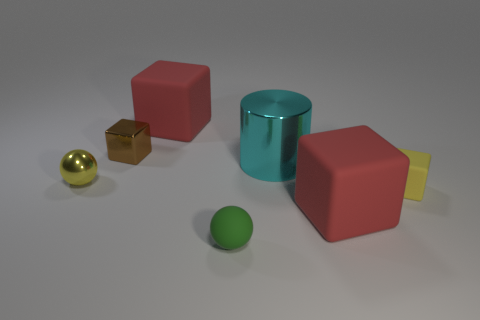Does the small rubber object that is on the right side of the metal cylinder have the same color as the large rubber object that is in front of the yellow metallic sphere?
Keep it short and to the point. No. What size is the rubber thing that is the same color as the metallic sphere?
Your answer should be very brief. Small. Is there a big cylinder that has the same material as the yellow block?
Your answer should be very brief. No. Are there the same number of tiny rubber things in front of the yellow cube and cyan things on the left side of the large cyan metallic object?
Make the answer very short. No. How big is the matte thing to the left of the green rubber ball?
Make the answer very short. Large. The large red object in front of the rubber object that is on the left side of the small matte ball is made of what material?
Provide a short and direct response. Rubber. There is a red rubber cube that is on the right side of the red matte cube that is behind the tiny brown block; how many brown cubes are on the right side of it?
Provide a succinct answer. 0. Do the red block on the left side of the green thing and the large thing in front of the big cyan shiny cylinder have the same material?
Provide a short and direct response. Yes. There is a block that is the same color as the small metal ball; what is its material?
Make the answer very short. Rubber. What number of other big cyan objects are the same shape as the large cyan object?
Your response must be concise. 0. 